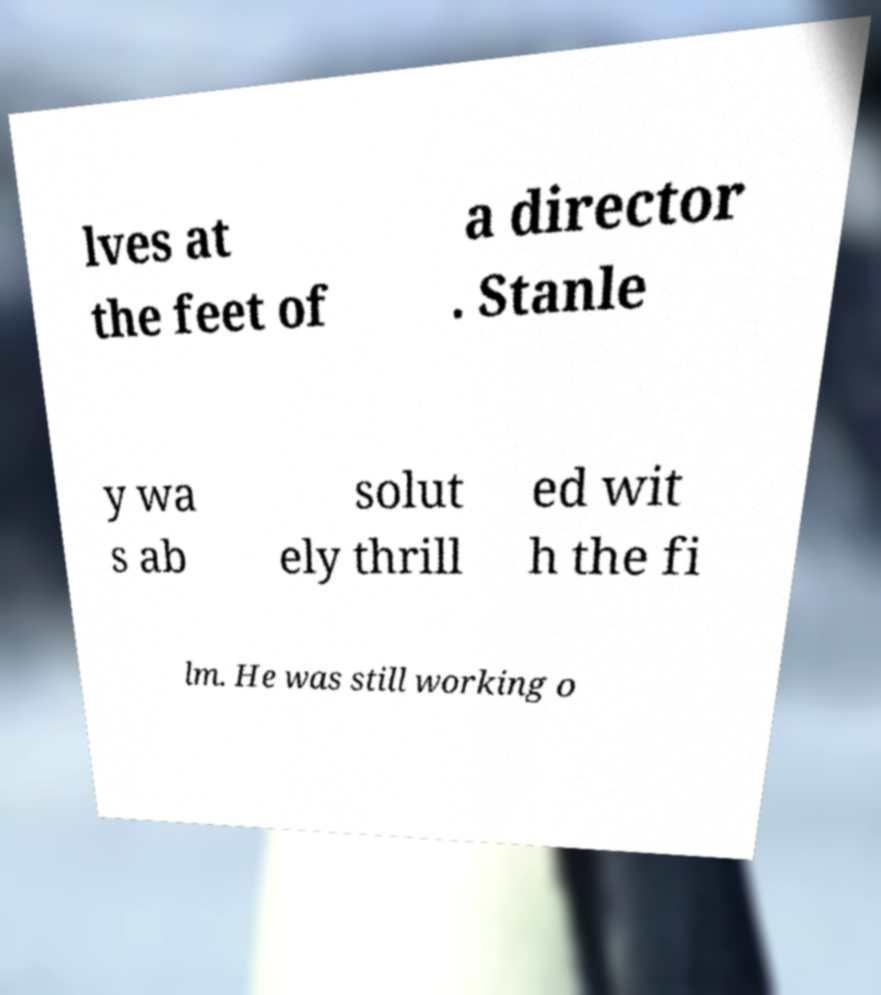There's text embedded in this image that I need extracted. Can you transcribe it verbatim? lves at the feet of a director . Stanle y wa s ab solut ely thrill ed wit h the fi lm. He was still working o 